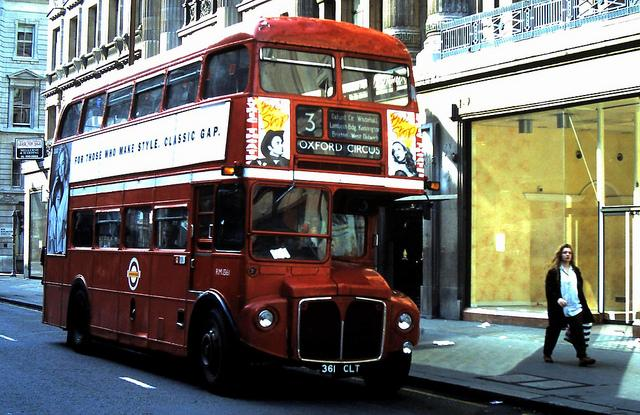What is one of the stops for this bus? oxford circus 